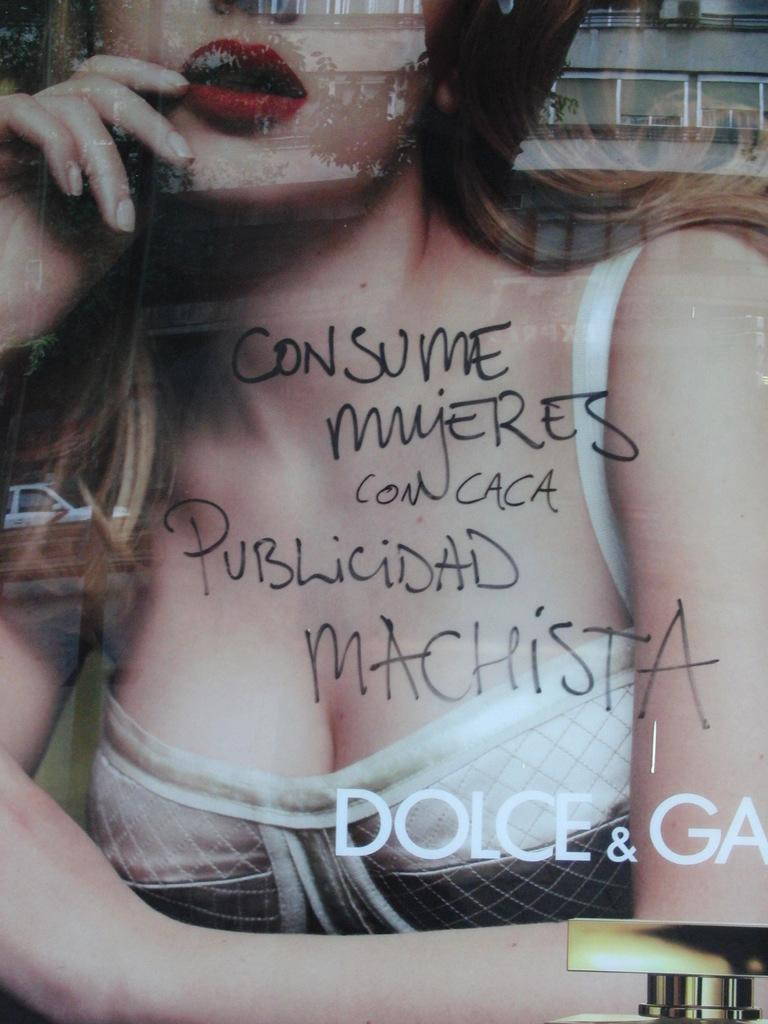What is the main subject of the image? The main subject of the image is a woman's picture. How is the woman's picture protected or displayed? The picture is behind a glass. What additional information is provided in the image? There is text above the woman's picture. What type of coach can be seen in the background of the image? There is no coach present in the image; it only features a woman's picture behind a glass with text above it. What type of produce is depicted in the image? There is no produce present in the image; it only features a woman's picture behind a glass with text above it. 